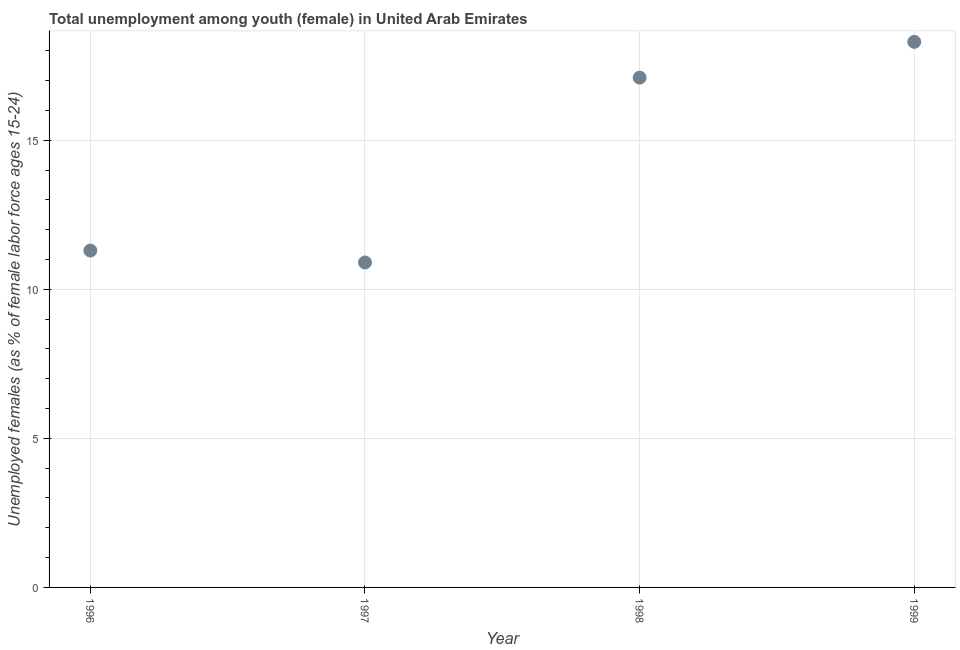What is the unemployed female youth population in 1997?
Your response must be concise. 10.9. Across all years, what is the maximum unemployed female youth population?
Provide a short and direct response. 18.3. Across all years, what is the minimum unemployed female youth population?
Offer a very short reply. 10.9. In which year was the unemployed female youth population maximum?
Your response must be concise. 1999. In which year was the unemployed female youth population minimum?
Your answer should be compact. 1997. What is the sum of the unemployed female youth population?
Give a very brief answer. 57.6. What is the difference between the unemployed female youth population in 1996 and 1997?
Offer a very short reply. 0.4. What is the average unemployed female youth population per year?
Your response must be concise. 14.4. What is the median unemployed female youth population?
Your answer should be very brief. 14.2. What is the ratio of the unemployed female youth population in 1998 to that in 1999?
Make the answer very short. 0.93. Is the unemployed female youth population in 1996 less than that in 1997?
Offer a very short reply. No. Is the difference between the unemployed female youth population in 1996 and 1997 greater than the difference between any two years?
Give a very brief answer. No. What is the difference between the highest and the second highest unemployed female youth population?
Your response must be concise. 1.2. Is the sum of the unemployed female youth population in 1997 and 1998 greater than the maximum unemployed female youth population across all years?
Make the answer very short. Yes. What is the difference between the highest and the lowest unemployed female youth population?
Your answer should be very brief. 7.4. In how many years, is the unemployed female youth population greater than the average unemployed female youth population taken over all years?
Offer a terse response. 2. How many dotlines are there?
Give a very brief answer. 1. How many years are there in the graph?
Offer a very short reply. 4. Does the graph contain grids?
Keep it short and to the point. Yes. What is the title of the graph?
Offer a very short reply. Total unemployment among youth (female) in United Arab Emirates. What is the label or title of the X-axis?
Provide a short and direct response. Year. What is the label or title of the Y-axis?
Provide a succinct answer. Unemployed females (as % of female labor force ages 15-24). What is the Unemployed females (as % of female labor force ages 15-24) in 1996?
Your response must be concise. 11.3. What is the Unemployed females (as % of female labor force ages 15-24) in 1997?
Keep it short and to the point. 10.9. What is the Unemployed females (as % of female labor force ages 15-24) in 1998?
Keep it short and to the point. 17.1. What is the Unemployed females (as % of female labor force ages 15-24) in 1999?
Your response must be concise. 18.3. What is the difference between the Unemployed females (as % of female labor force ages 15-24) in 1996 and 1997?
Your answer should be very brief. 0.4. What is the difference between the Unemployed females (as % of female labor force ages 15-24) in 1996 and 1999?
Give a very brief answer. -7. What is the difference between the Unemployed females (as % of female labor force ages 15-24) in 1997 and 1998?
Give a very brief answer. -6.2. What is the difference between the Unemployed females (as % of female labor force ages 15-24) in 1997 and 1999?
Your answer should be compact. -7.4. What is the difference between the Unemployed females (as % of female labor force ages 15-24) in 1998 and 1999?
Provide a succinct answer. -1.2. What is the ratio of the Unemployed females (as % of female labor force ages 15-24) in 1996 to that in 1998?
Give a very brief answer. 0.66. What is the ratio of the Unemployed females (as % of female labor force ages 15-24) in 1996 to that in 1999?
Your answer should be very brief. 0.62. What is the ratio of the Unemployed females (as % of female labor force ages 15-24) in 1997 to that in 1998?
Ensure brevity in your answer.  0.64. What is the ratio of the Unemployed females (as % of female labor force ages 15-24) in 1997 to that in 1999?
Offer a terse response. 0.6. What is the ratio of the Unemployed females (as % of female labor force ages 15-24) in 1998 to that in 1999?
Provide a short and direct response. 0.93. 